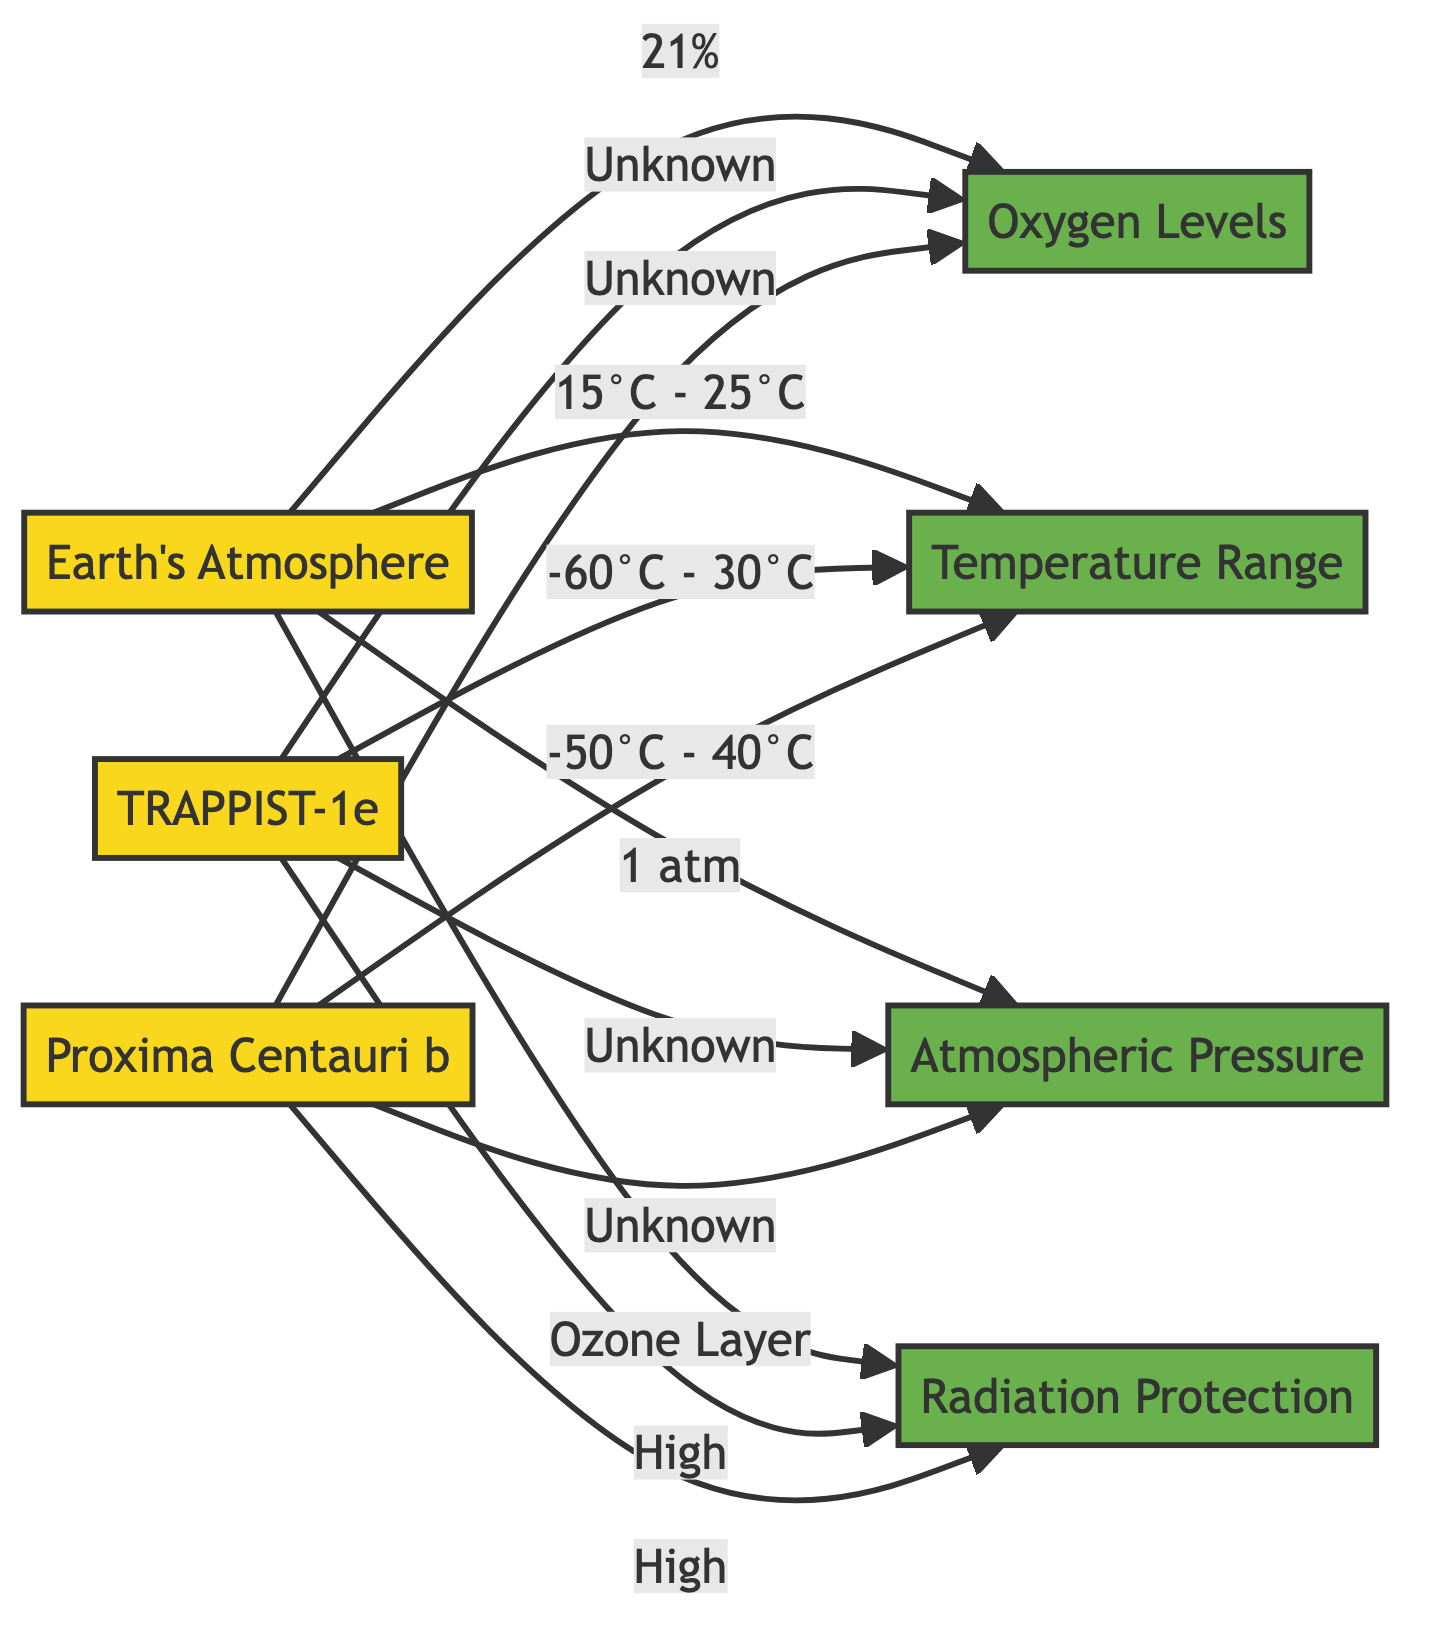What is the percentage of oxygen in Earth's atmosphere? The diagram indicates that Earth's atmosphere contains 21% oxygen, as stated directly in the connection from the Earth node to the Oxygen Levels node.
Answer: 21% What is the temperature range for TRAPPIST-1e? According to the diagram, the temperature range for TRAPPIST-1e is from -60 degrees Celsius to 30 degrees Celsius, which is clearly labeled in the connection from the TRAPPIST-1e node to the Temperature Range node.
Answer: -60°C - 30°C How many exoplanets are compared in the diagram? The diagram displays two exoplanets (TRAPPIST-1e and Proxima Centauri b) in addition to Earth, totaling three planets in the comparison.
Answer: 3 What type of radiation protection does Earth have? The diagram shows that Earth is protected by an ozone layer, as indicated in the connection from the Earth node to the Radiation Protection node.
Answer: Ozone Layer Which exoplanet has a temperature range that includes negative values? By analyzing both exoplanets' temperature ranges, TRAPPIST-1e is the only one that features negative temperatures in the range from -60 degrees Celsius to 30 degrees Celsius.
Answer: TRAPPIST-1e What do the two exoplanets have in common regarding radiation? Both exoplanets, TRAPPIST-1e and Proxima Centauri b, have high radiation levels, as indicated in their respective connections to the Radiation Protection node.
Answer: High What is the atmospheric pressure for Earth? The diagram states that Earth's atmospheric pressure is 1 atmosphere, as detailed in the connection from the Earth node to the Atmospheric Pressure node.
Answer: 1 atm Which exoplanet has a wider temperature range? Comparing the temperature ranges, TRAPPIST-1e has a wider range from -60 degrees Celsius to 30 degrees Celsius compared to Proxima Centauri b, which ranges from -50 degrees Celsius to 40 degrees Celsius.
Answer: TRAPPIST-1e What information is missing for TRAPPIST-1e regarding atmospheric pressure? The diagram indicates that the atmospheric pressure for TRAPPIST-1e is listed as unknown, due to the lack of data provided in the connection from the exoplanet node to the Atmospheric Pressure node.
Answer: Unknown 